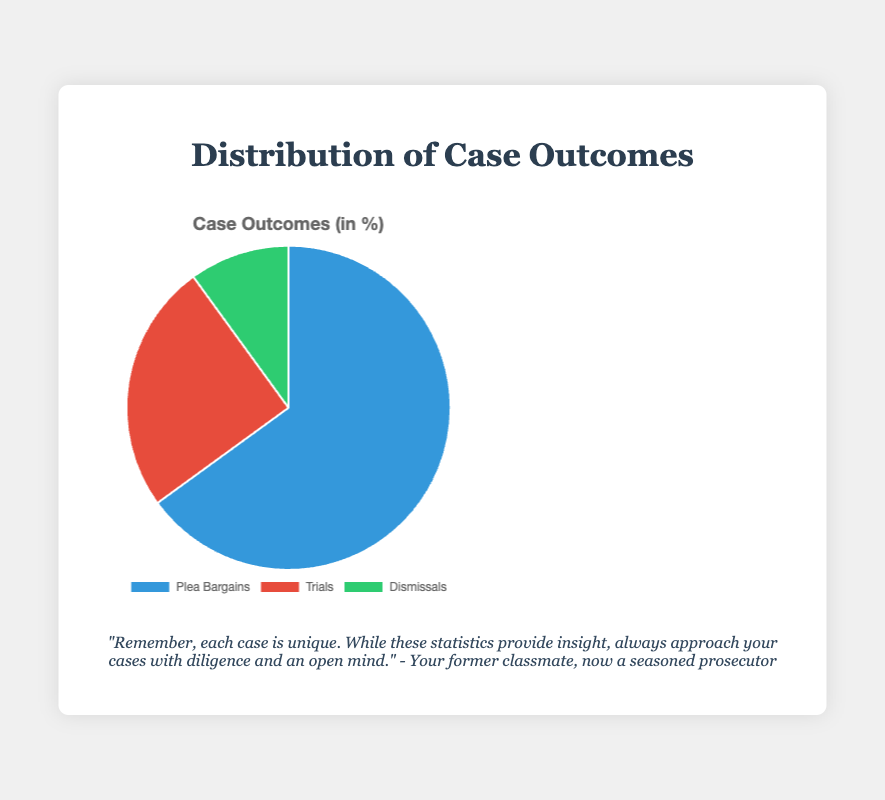What is the most common outcome for cases in the chart? The chart shows the distribution of case outcomes, and the largest portion of the pie chart is labeled "Plea Bargains" with 65%. Therefore, plea bargains are the most common outcome.
Answer: Plea Bargains How many times greater is the percentage of plea bargains compared to dismissals? Plea bargains make up 65% of the cases, and dismissals make up 10%. To find out how many times greater 65% is compared to 10%, divide 65 by 10.
Answer: 6.5 times What percentage of cases go to trial according to the chart? The chart has a segment labeled "Trials" which accounts for 25% of the cases.
Answer: 25% What is the combined percentage of plea bargains and trials? Plea bargains account for 65% of the cases, and trials account for 25%. Adding these together gives 65 + 25 = 90%.
Answer: 90% Which outcome is represented by the smallest segment of the chart, and what is its percentage? The smallest segment is labeled "Dismissals" and accounts for 10% of the cases.
Answer: Dismissals, 10% If the distribution of case outcomes were displayed again but only included plea bargains and trials, what would the new percentage for trials be? Initially, plea bargains are 65% and trials are 25% out of a total of 100%. For the new distribution, we exclude dismissals (10%), leaving a total of 65 + 25 = 90%. The new percentage for trials is calculated as (25 / 90) * 100%.
Answer: 27.78% What is the difference in percentage between trials and dismissals? Trials make up 25% of the cases, and dismissals make up 10%. Subtract 10 from 25.
Answer: 15% What color represents dismissals on the pie chart? The chart uses green to represent the dismissals segment.
Answer: green If you are planning to focus on reducing trials by 5%, what would be the new percentage distribution for trials and plea bargains? Currently, trials are 25% and plea bargains are 65%. Reducing trials by 5% would make them 20%. The total distribution would still add up to 100%; hence, the new distribution for plea bargains would be 65 + 5 = 70%.
Answer: Trials: 20%, Plea Bargains: 70% Which segment would you target for improvement if you aimed to drastically reduce court workload, and why? Plea bargains form 65% of the cases, which is the largest segment. Targeting a reduction in plea bargains could have a significant impact on the court workload.
Answer: Plea Bargains 